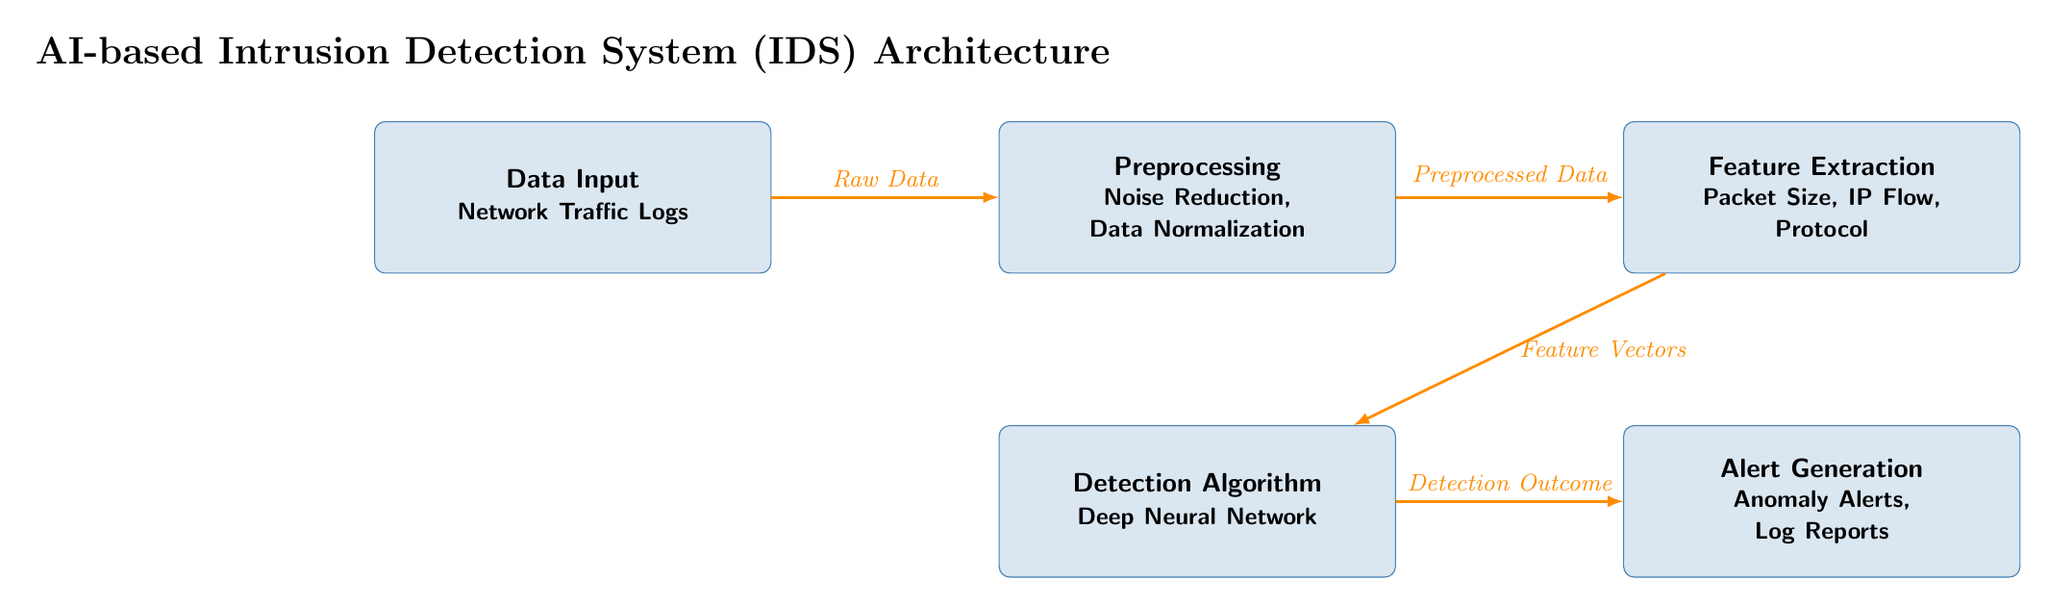What is the first step in the AI-based Intrusion Detection System architecture? The first node in the diagram is labeled "Data Input," which indicates that the initial step involves collecting data, specifically network traffic logs.
Answer: Data Input How many main processing steps are in the diagram? The diagram showcases five main processing steps: Data Input, Preprocessing, Feature Extraction, Detection Algorithm, and Alert Generation.
Answer: Five What type of data is processed in the "Preprocessing" step? The "Preprocessing" node mentions "Noise Reduction" and "Data Normalization," which indicates that the data being processed is concerned with cleaning and standardizing the input data.
Answer: Noise Reduction, Data Normalization Which step directly follows "Feature Extraction"? The step that follows "Feature Extraction" in the diagram is the "Detection Algorithm" step, which utilizes the features extracted from the data to identify anomalies.
Answer: Detection Algorithm What is the final output generated in this architecture? The last node in the flowchart is "Alert Generation," and it specifies that the final output consists of "Anomaly Alerts" and "Log Reports," indicating this is the conclusive step of the process.
Answer: Alert Generation Which step uses a Deep Neural Network? The "Detection Algorithm" node explicitly states that a Deep Neural Network is the method used for analyzing the preprocessed data and determining anomalies.
Answer: Detection Algorithm What type of alerts are generated in the last step? The last processing step titled "Alert Generation" notes the creation of "Anomaly Alerts" and "Log Reports," showing the specific types of alerts produced after detection.
Answer: Anomaly Alerts, Log Reports How does the information flow from "Data Input" to "Preprocessing"? The flow from "Data Input" to "Preprocessing" is represented by a direct line labeled "Raw Data," indicating that the data in its original form is handed off to the preprocessing stage for further refinement.
Answer: Raw Data What is the relationship between "Preprocessing" and "Feature Extraction"? The relationship between "Preprocessing" and "Feature Extraction" is shown by an arrow labeled "Preprocessed Data," which implies that the cleaned data from the preprocessing step is transformed into features for the next step.
Answer: Preprocessed Data 